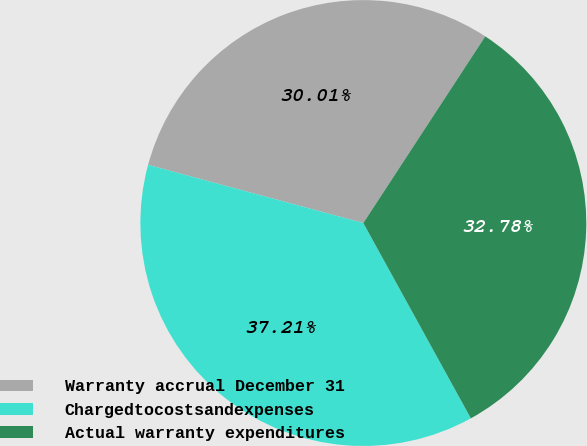<chart> <loc_0><loc_0><loc_500><loc_500><pie_chart><fcel>Warranty accrual December 31<fcel>Chargedtocostsandexpenses<fcel>Actual warranty expenditures<nl><fcel>30.01%<fcel>37.21%<fcel>32.78%<nl></chart> 